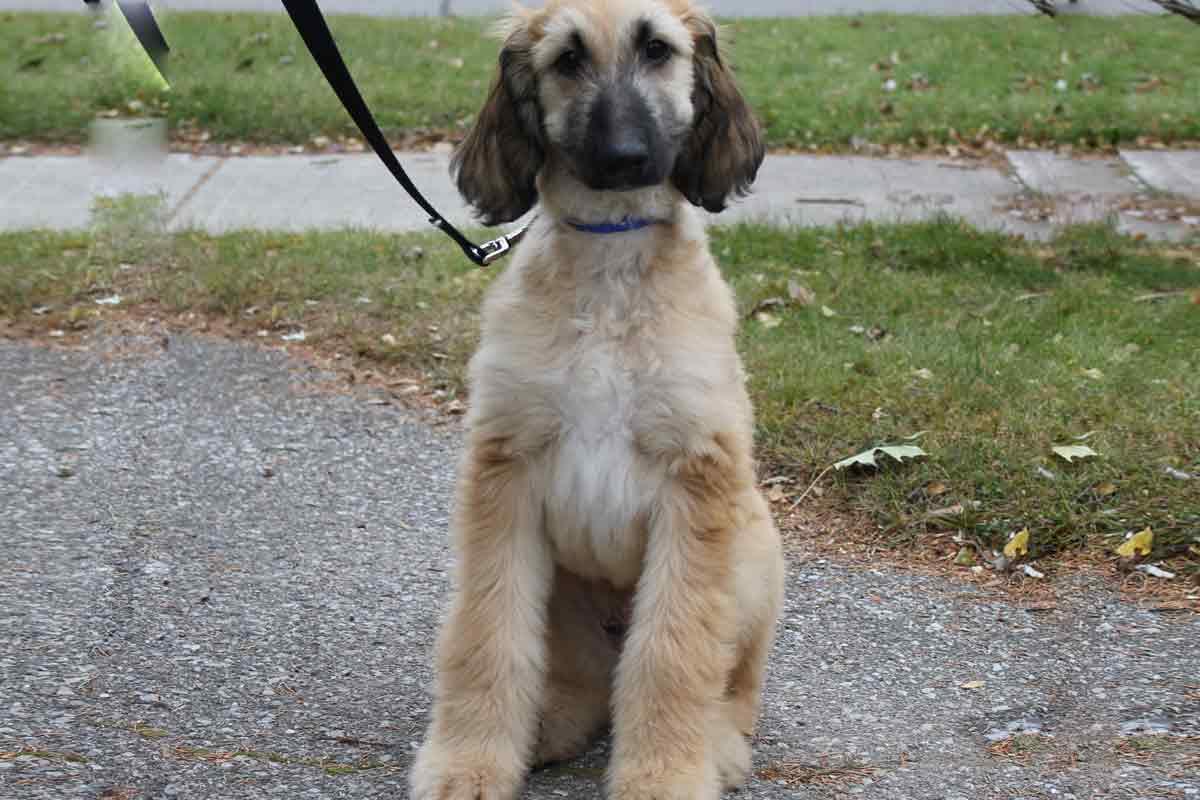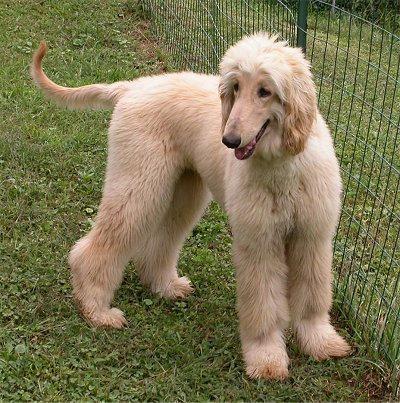The first image is the image on the left, the second image is the image on the right. For the images shown, is this caption "There are two dogs facing each other." true? Answer yes or no. No. The first image is the image on the left, the second image is the image on the right. For the images displayed, is the sentence "2 walking dogs have curled tails." factually correct? Answer yes or no. No. 